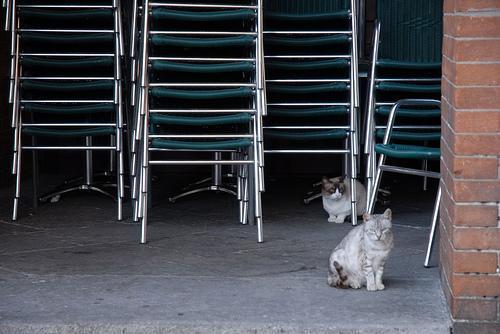How many cats are in the picture?
Give a very brief answer. 2. How many chairs are there?
Give a very brief answer. 11. How many sandwiches with orange paste are in the picture?
Give a very brief answer. 0. 